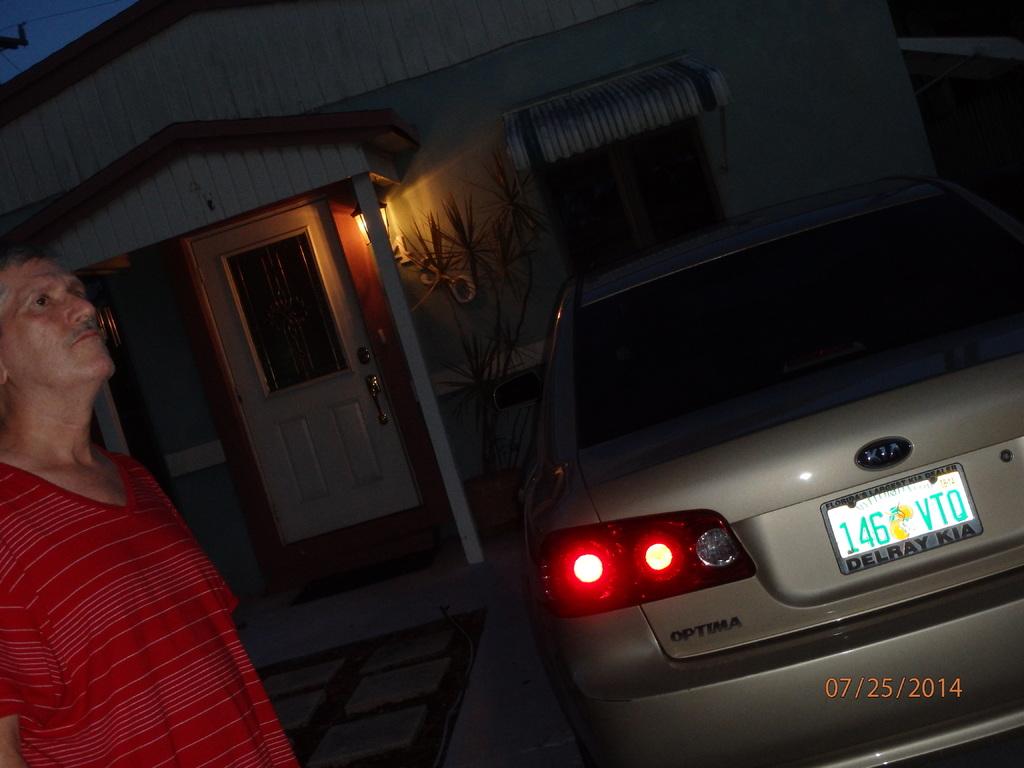On what date was this image taken according to the camera?
Your answer should be compact. 07/25/2014. What is the liscense plate?
Ensure brevity in your answer.  146 vtq. 